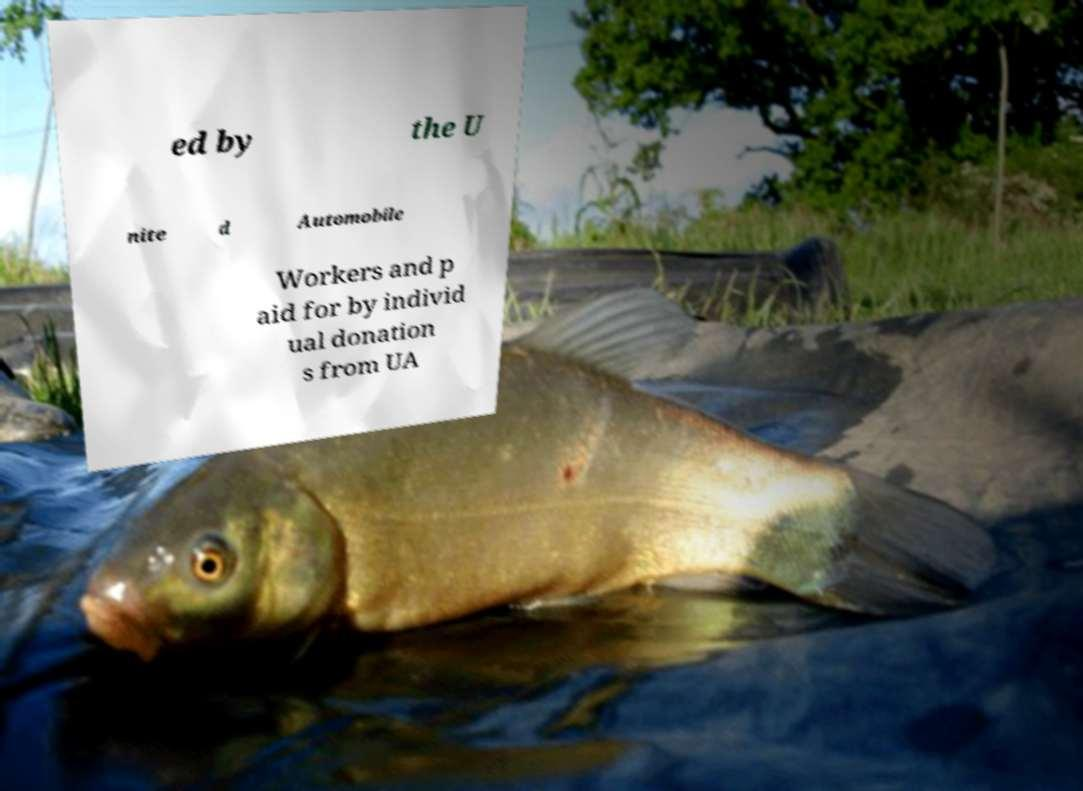For documentation purposes, I need the text within this image transcribed. Could you provide that? ed by the U nite d Automobile Workers and p aid for by individ ual donation s from UA 